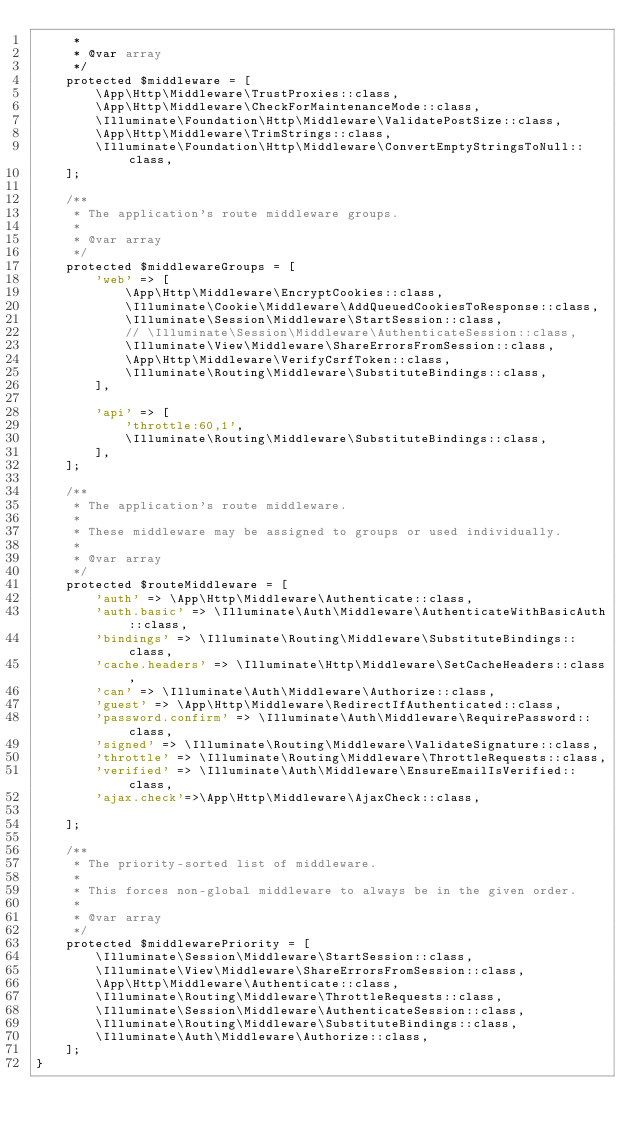Convert code to text. <code><loc_0><loc_0><loc_500><loc_500><_PHP_>     *
     * @var array
     */
    protected $middleware = [
        \App\Http\Middleware\TrustProxies::class,
        \App\Http\Middleware\CheckForMaintenanceMode::class,
        \Illuminate\Foundation\Http\Middleware\ValidatePostSize::class,
        \App\Http\Middleware\TrimStrings::class,
        \Illuminate\Foundation\Http\Middleware\ConvertEmptyStringsToNull::class,
    ];

    /**
     * The application's route middleware groups.
     *
     * @var array
     */
    protected $middlewareGroups = [
        'web' => [
            \App\Http\Middleware\EncryptCookies::class,
            \Illuminate\Cookie\Middleware\AddQueuedCookiesToResponse::class,
            \Illuminate\Session\Middleware\StartSession::class,
            // \Illuminate\Session\Middleware\AuthenticateSession::class,
            \Illuminate\View\Middleware\ShareErrorsFromSession::class,
            \App\Http\Middleware\VerifyCsrfToken::class,
            \Illuminate\Routing\Middleware\SubstituteBindings::class,
        ],

        'api' => [
            'throttle:60,1',
            \Illuminate\Routing\Middleware\SubstituteBindings::class,
        ],
    ];

    /**
     * The application's route middleware.
     *
     * These middleware may be assigned to groups or used individually.
     *
     * @var array
     */
    protected $routeMiddleware = [
        'auth' => \App\Http\Middleware\Authenticate::class,
        'auth.basic' => \Illuminate\Auth\Middleware\AuthenticateWithBasicAuth::class,
        'bindings' => \Illuminate\Routing\Middleware\SubstituteBindings::class,
        'cache.headers' => \Illuminate\Http\Middleware\SetCacheHeaders::class,
        'can' => \Illuminate\Auth\Middleware\Authorize::class,
        'guest' => \App\Http\Middleware\RedirectIfAuthenticated::class,
        'password.confirm' => \Illuminate\Auth\Middleware\RequirePassword::class,
        'signed' => \Illuminate\Routing\Middleware\ValidateSignature::class,
        'throttle' => \Illuminate\Routing\Middleware\ThrottleRequests::class,
        'verified' => \Illuminate\Auth\Middleware\EnsureEmailIsVerified::class,
        'ajax.check'=>\App\Http\Middleware\AjaxCheck::class,

    ];

    /**
     * The priority-sorted list of middleware.
     *
     * This forces non-global middleware to always be in the given order.
     *
     * @var array
     */
    protected $middlewarePriority = [
        \Illuminate\Session\Middleware\StartSession::class,
        \Illuminate\View\Middleware\ShareErrorsFromSession::class,
        \App\Http\Middleware\Authenticate::class,
        \Illuminate\Routing\Middleware\ThrottleRequests::class,
        \Illuminate\Session\Middleware\AuthenticateSession::class,
        \Illuminate\Routing\Middleware\SubstituteBindings::class,
        \Illuminate\Auth\Middleware\Authorize::class,
    ];
}
</code> 